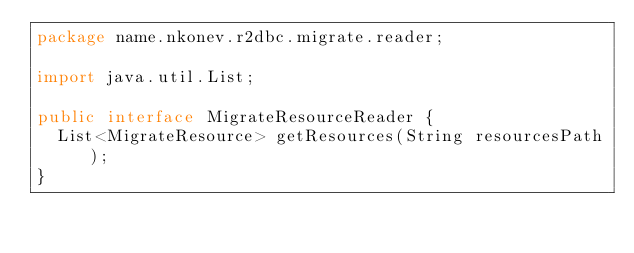<code> <loc_0><loc_0><loc_500><loc_500><_Java_>package name.nkonev.r2dbc.migrate.reader;

import java.util.List;

public interface MigrateResourceReader {
  List<MigrateResource> getResources(String resourcesPath);
}
</code> 